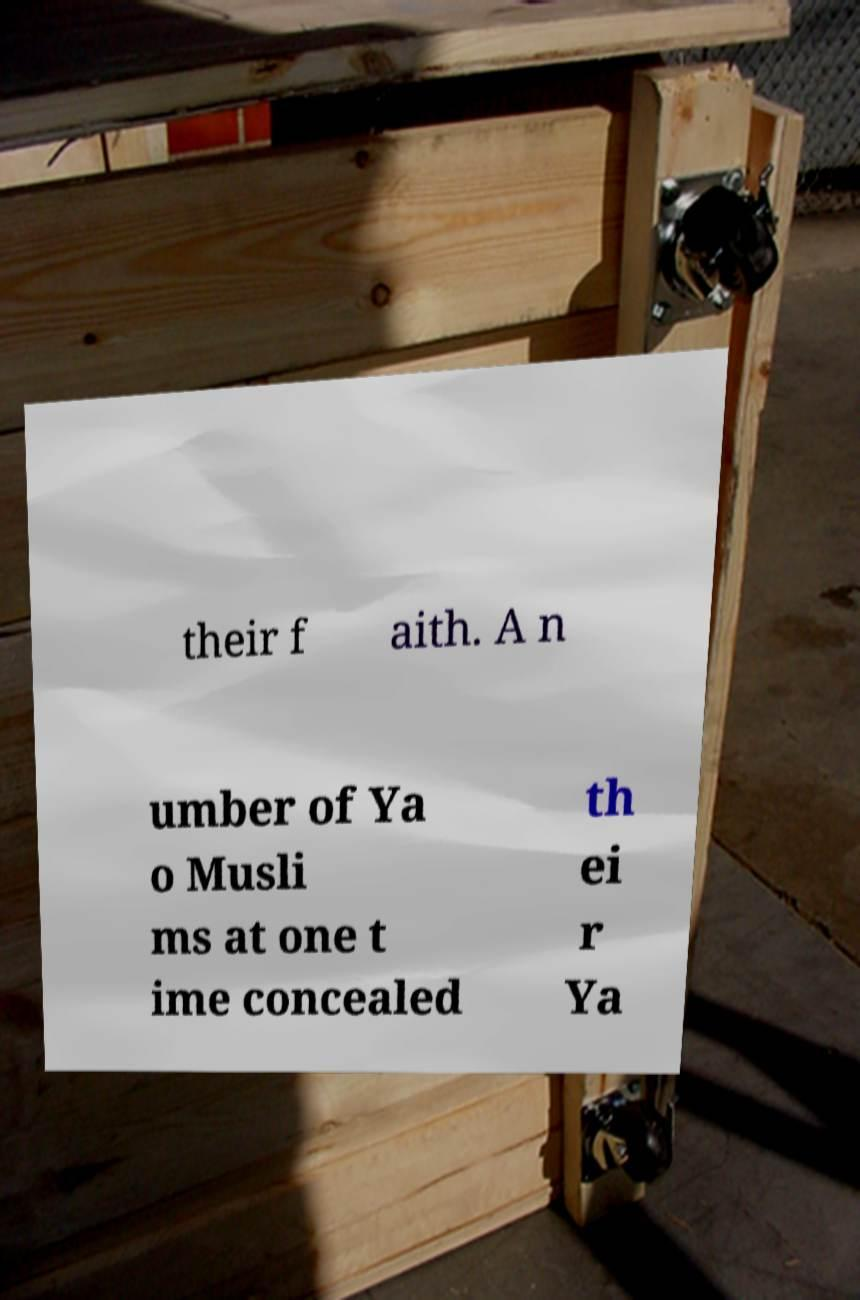Please identify and transcribe the text found in this image. their f aith. A n umber of Ya o Musli ms at one t ime concealed th ei r Ya 